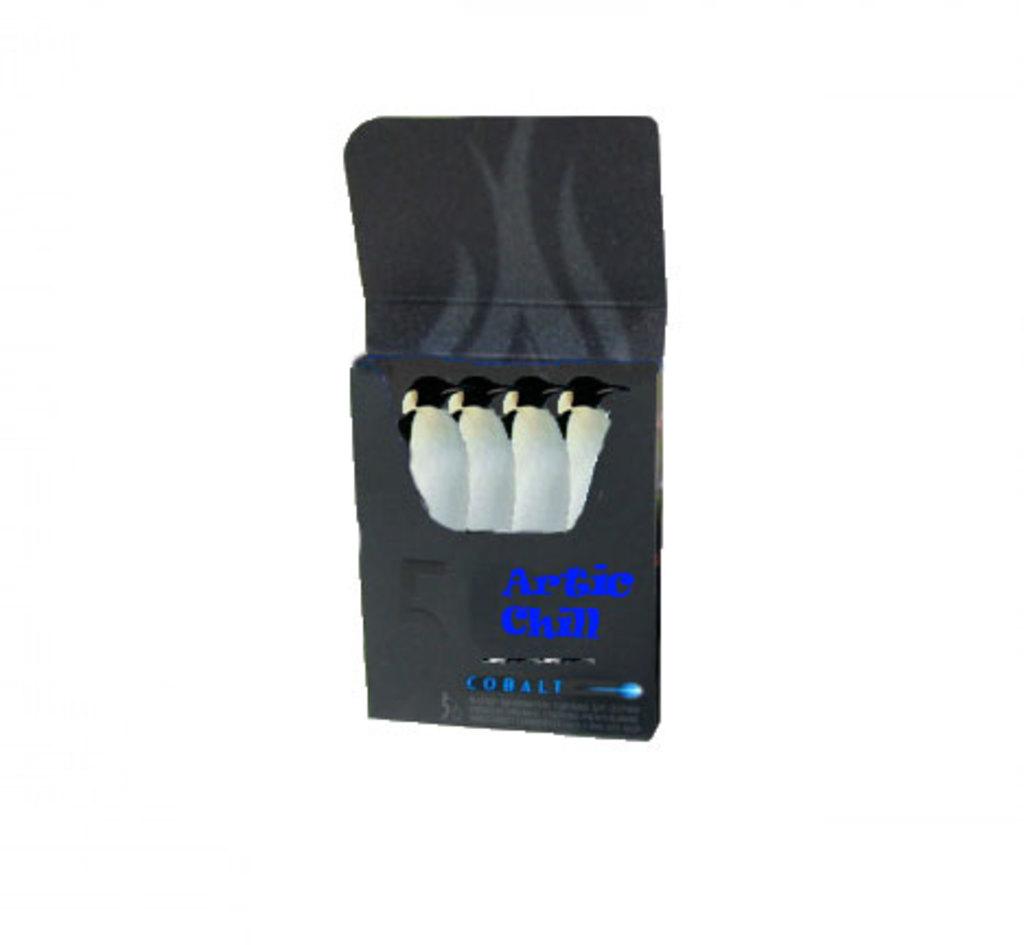What kind of chill?
Your response must be concise. Artic. What is the number shown in the picture?
Your response must be concise. 5. 